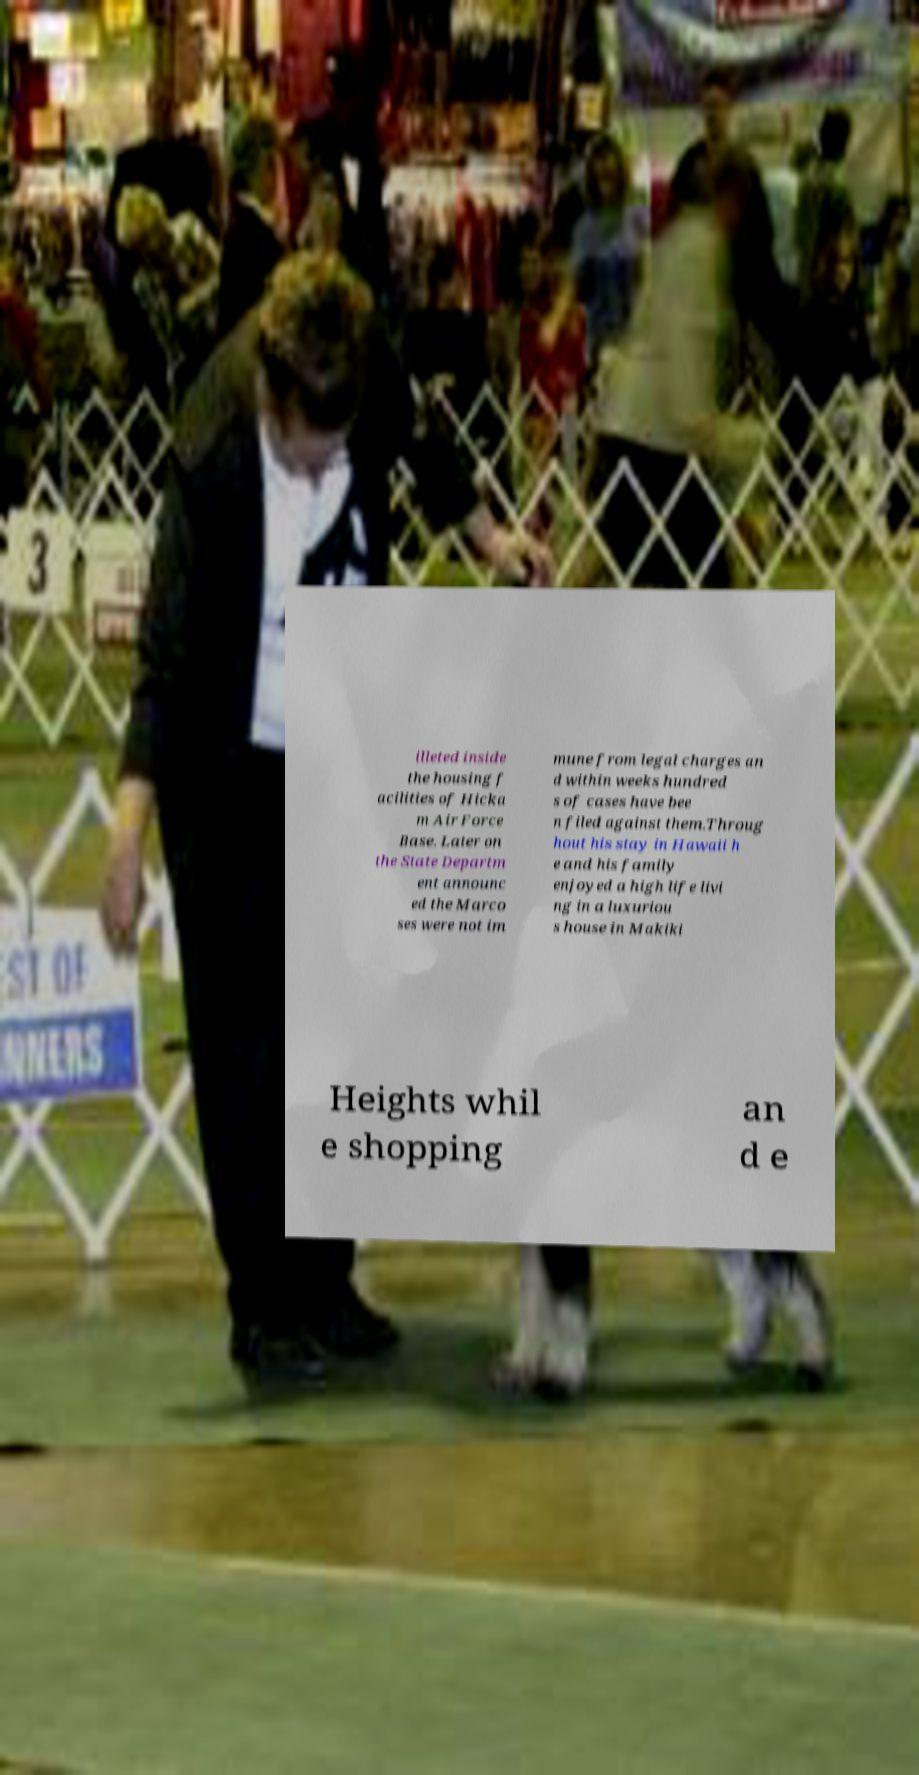Please identify and transcribe the text found in this image. illeted inside the housing f acilities of Hicka m Air Force Base. Later on the State Departm ent announc ed the Marco ses were not im mune from legal charges an d within weeks hundred s of cases have bee n filed against them.Throug hout his stay in Hawaii h e and his family enjoyed a high life livi ng in a luxuriou s house in Makiki Heights whil e shopping an d e 